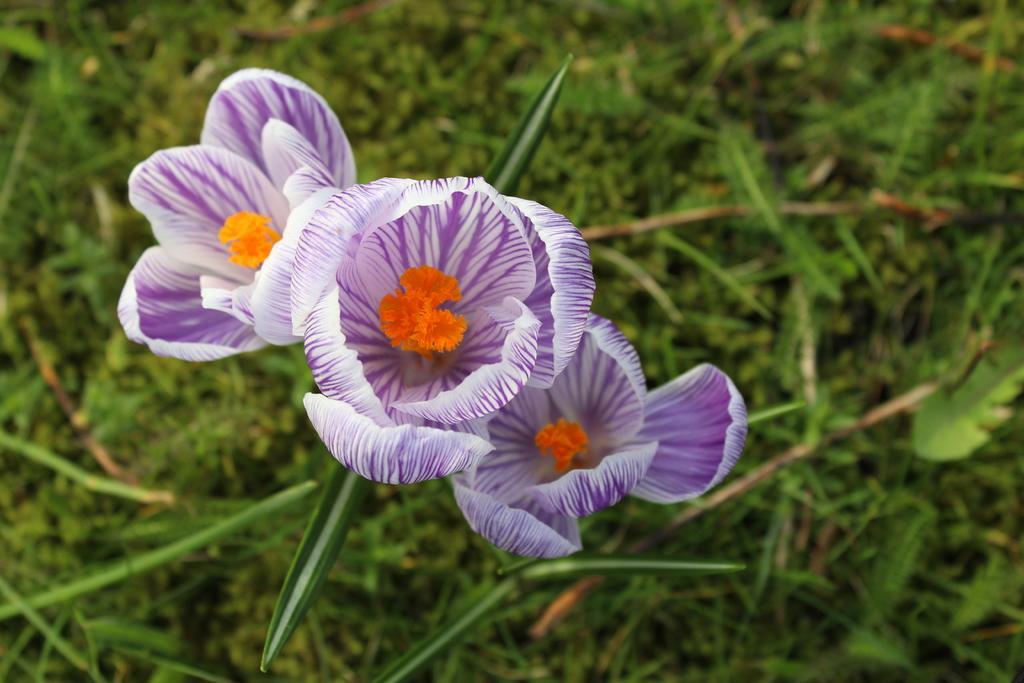Could you give a brief overview of what you see in this image? In this image I can see a flowering plant and grass. This image is taken may be in a garden during a day. 